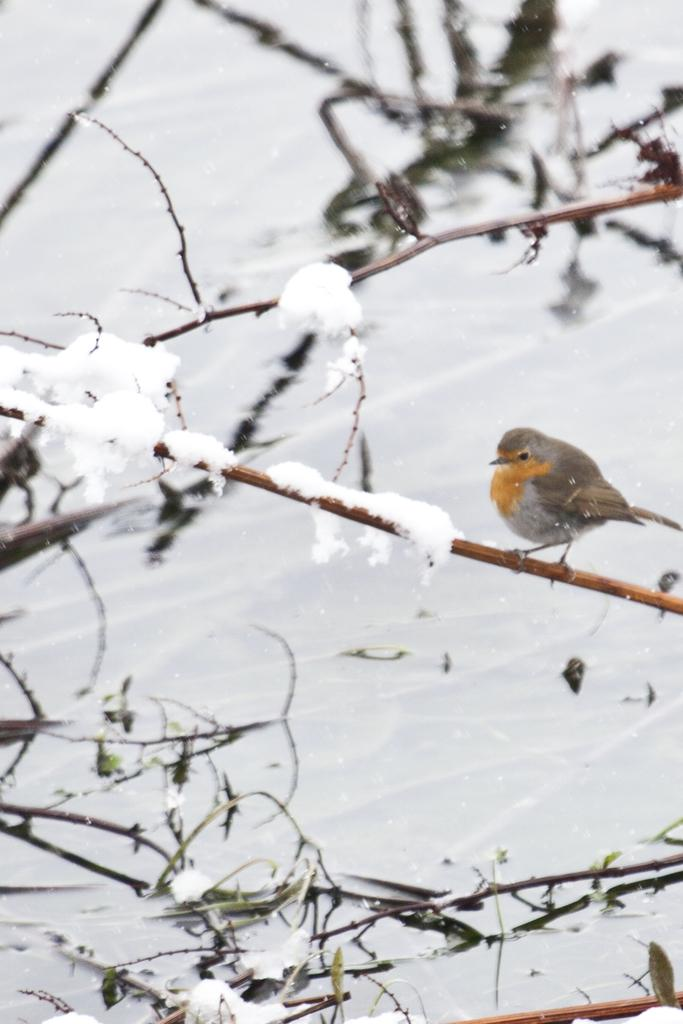What type of animal can be seen in the image? There is a bird in the image. Where is the bird located? The bird is on a stem in the image. What can be seen in the background of the image? There is water and snow visible in the background of the image. What type of wool is the bird using to knit a sweater in the image? There is no wool or sweater present in the image; it features a bird on a stem with water and snow in the background. 